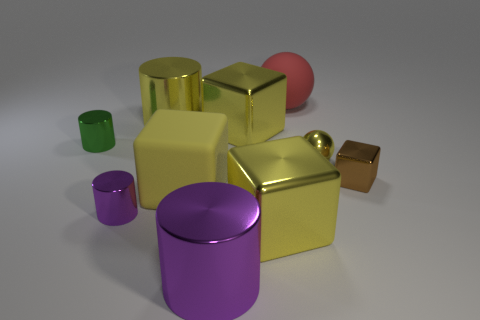Subtract all yellow spheres. How many yellow blocks are left? 3 Subtract all spheres. How many objects are left? 8 Add 5 big red spheres. How many big red spheres exist? 6 Subtract 0 cyan cubes. How many objects are left? 10 Subtract all tiny red matte cylinders. Subtract all metal cylinders. How many objects are left? 6 Add 1 brown objects. How many brown objects are left? 2 